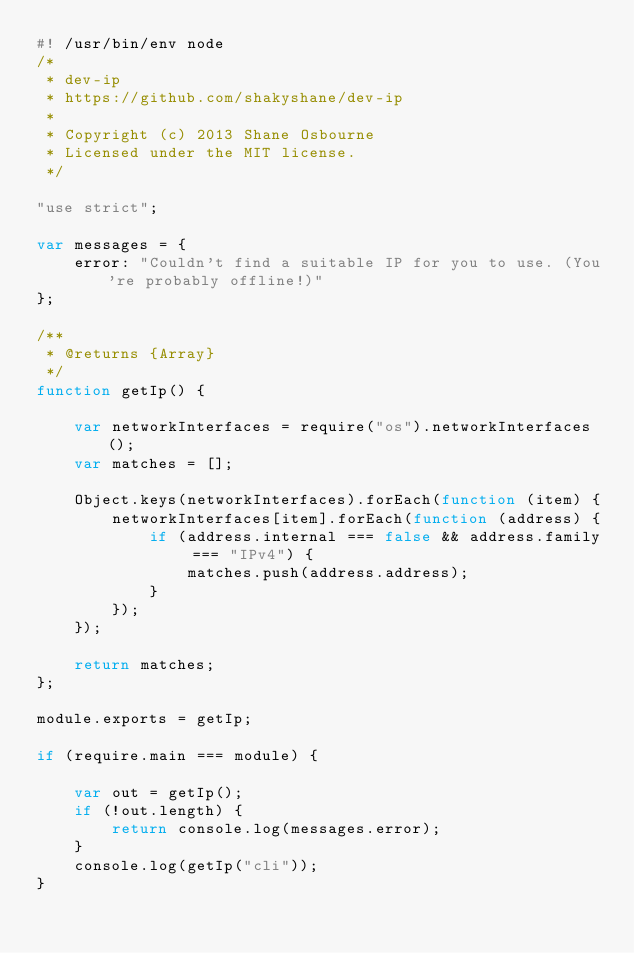<code> <loc_0><loc_0><loc_500><loc_500><_JavaScript_>#! /usr/bin/env node
/*
 * dev-ip
 * https://github.com/shakyshane/dev-ip
 *
 * Copyright (c) 2013 Shane Osbourne
 * Licensed under the MIT license.
 */

"use strict";

var messages = {
    error: "Couldn't find a suitable IP for you to use. (You're probably offline!)"
};

/**
 * @returns {Array}
 */
function getIp() {

    var networkInterfaces = require("os").networkInterfaces();
    var matches = [];

    Object.keys(networkInterfaces).forEach(function (item) {
        networkInterfaces[item].forEach(function (address) {
            if (address.internal === false && address.family === "IPv4") {
                matches.push(address.address);
            }
        });
    });

    return matches;
};

module.exports = getIp;

if (require.main === module) {

    var out = getIp();
    if (!out.length) {
        return console.log(messages.error);
    }
    console.log(getIp("cli"));
}</code> 